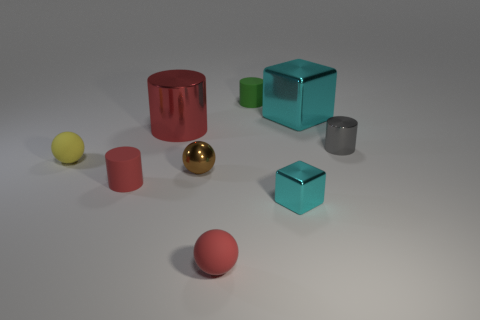Subtract all cyan cylinders. Subtract all cyan blocks. How many cylinders are left? 4 Add 1 large things. How many objects exist? 10 Subtract all cubes. How many objects are left? 7 Add 7 tiny yellow spheres. How many tiny yellow spheres are left? 8 Add 6 large gray rubber things. How many large gray rubber things exist? 6 Subtract 1 gray cylinders. How many objects are left? 8 Subtract all gray matte blocks. Subtract all cylinders. How many objects are left? 5 